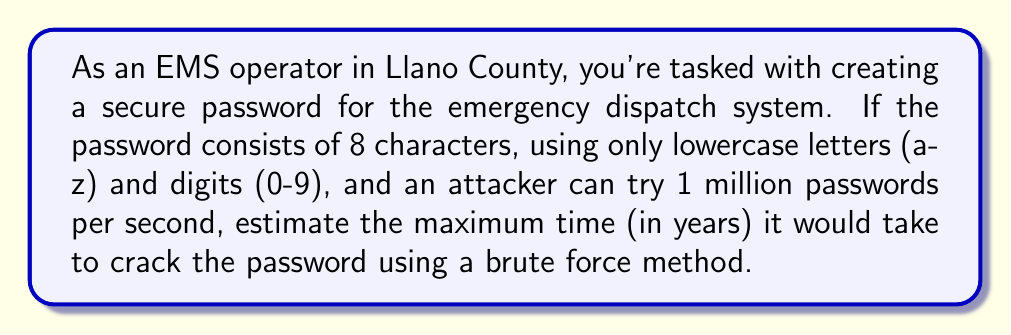What is the answer to this math problem? Let's approach this step-by-step:

1) First, we need to calculate the total number of possible passwords:
   - There are 26 lowercase letters and 10 digits, so 36 possible characters for each position.
   - The password is 8 characters long.
   - Total possible passwords = $36^8$

2) Calculate the total number of possible passwords:
   $36^8 = 2,821,109,907,456$ ≈ $2.82 \times 10^{12}$

3) Given that the attacker can try 1 million ($ 10^6 $) passwords per second, we can calculate the time in seconds:
   $\text{Time (seconds)} = \frac{2.82 \times 10^{12}}{10^6} = 2.82 \times 10^6 \text{ seconds}$

4) Convert seconds to years:
   $\text{Time (years)} = \frac{2.82 \times 10^6 \text{ seconds}}{60 \text{ sec/min} \times 60 \text{ min/hour} \times 24 \text{ hours/day} \times 365.25 \text{ days/year}}$

5) Simplify:
   $\text{Time (years)} = \frac{2.82 \times 10^6}{31,557,600} \approx 0.0894 \text{ years}$

Therefore, it would take approximately 0.0894 years or about 32.6 days to try all possible passwords in the worst-case scenario.
Answer: 0.0894 years 